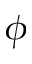Convert formula to latex. <formula><loc_0><loc_0><loc_500><loc_500>\phi</formula> 